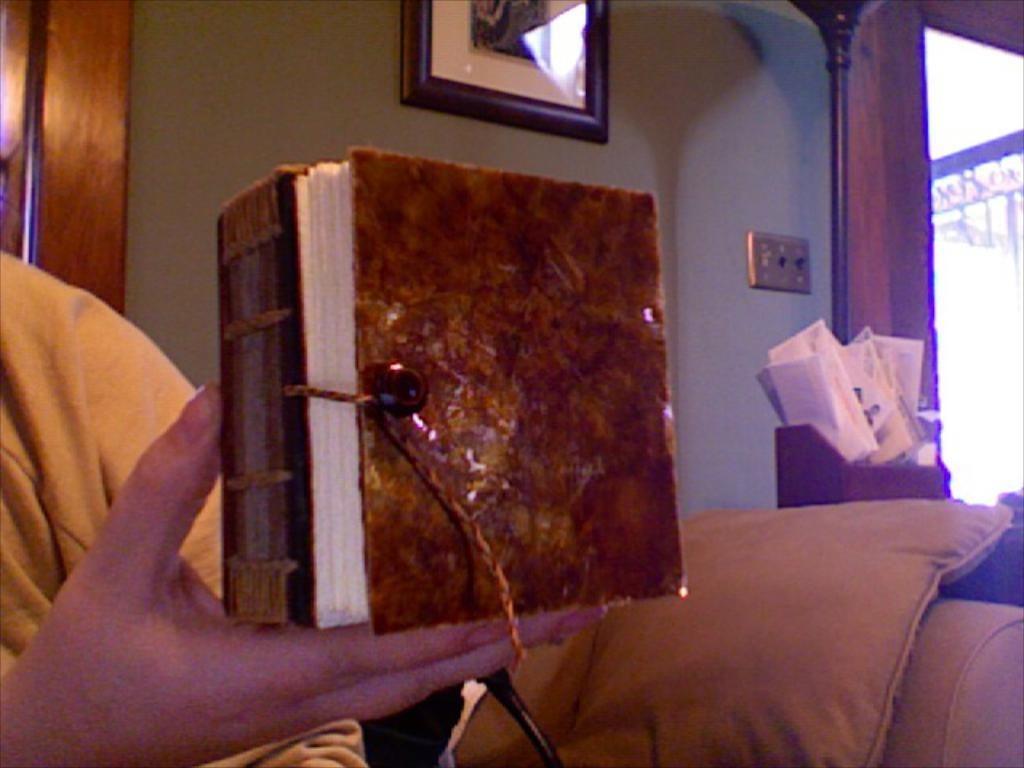What is the main focus of the image? The main focus of the image is a person's hand holding an object in the center of the image. What can be seen in the background of the image? In the background of the image, there is a wall, a frame, a pillow, papers, and a few other objects. Can you describe the wall in the background? The wall is a part of the background in the image. What might the papers in the background be related to? The papers in the background could be related to documents, notes, or other written materials. What type of waste can be seen in the image? There is no waste present in the image. Can you describe the veins in the person's hand holding the object? The image does not show the veins in the person's hand holding the object; it only shows the hand and the object it is holding. 